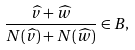<formula> <loc_0><loc_0><loc_500><loc_500>\frac { \widehat { v } + \widehat { w } } { N ( \widehat { v } ) + N ( \widehat { w } ) } \in B ,</formula> 